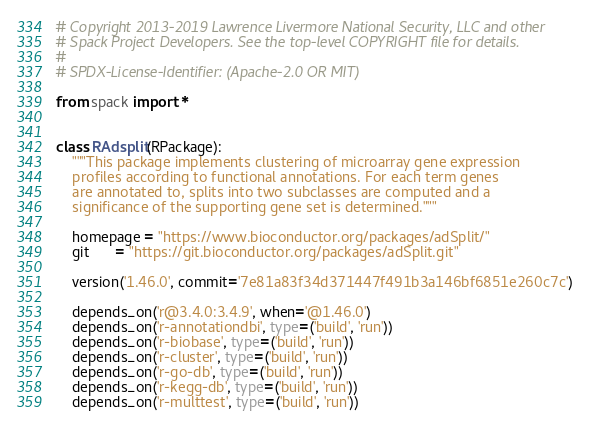<code> <loc_0><loc_0><loc_500><loc_500><_Python_># Copyright 2013-2019 Lawrence Livermore National Security, LLC and other
# Spack Project Developers. See the top-level COPYRIGHT file for details.
#
# SPDX-License-Identifier: (Apache-2.0 OR MIT)

from spack import *


class RAdsplit(RPackage):
    """This package implements clustering of microarray gene expression
    profiles according to functional annotations. For each term genes
    are annotated to, splits into two subclasses are computed and a
    significance of the supporting gene set is determined."""

    homepage = "https://www.bioconductor.org/packages/adSplit/"
    git      = "https://git.bioconductor.org/packages/adSplit.git"

    version('1.46.0', commit='7e81a83f34d371447f491b3a146bf6851e260c7c')

    depends_on('r@3.4.0:3.4.9', when='@1.46.0')
    depends_on('r-annotationdbi', type=('build', 'run'))
    depends_on('r-biobase', type=('build', 'run'))
    depends_on('r-cluster', type=('build', 'run'))
    depends_on('r-go-db', type=('build', 'run'))
    depends_on('r-kegg-db', type=('build', 'run'))
    depends_on('r-multtest', type=('build', 'run'))
</code> 